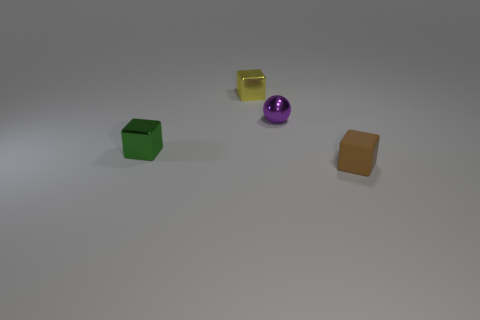What number of other objects are there of the same material as the green thing?
Your answer should be compact. 2. Is there a green object behind the tiny shiny object on the right side of the metallic cube right of the small green shiny block?
Offer a terse response. No. Is the material of the brown thing the same as the small purple sphere?
Offer a terse response. No. Are there any other things that are the same shape as the tiny purple shiny object?
Give a very brief answer. No. What material is the small thing that is left of the tiny metallic cube that is behind the purple metal sphere made of?
Provide a succinct answer. Metal. There is a thing that is in front of the small green metallic object; what is its size?
Keep it short and to the point. Small. What is the color of the cube that is both in front of the small purple ball and left of the tiny purple metal thing?
Provide a succinct answer. Green. Do the metallic object that is behind the sphere and the tiny purple thing have the same size?
Provide a succinct answer. Yes. There is a small metallic thing that is in front of the tiny purple metallic ball; are there any blocks behind it?
Keep it short and to the point. Yes. What is the material of the small yellow object?
Keep it short and to the point. Metal. 